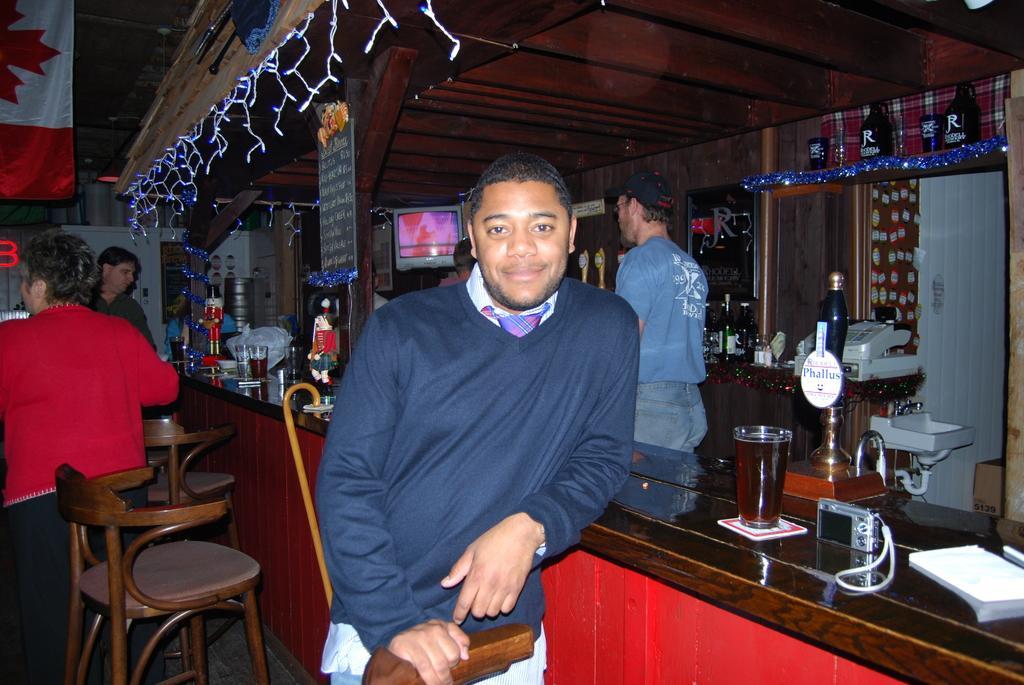Can you describe this image briefly? Front this man wore blue t-shirt and smiling and kept his hand on this table. On this table there are glasses, toys, camera and book. These persons are standing. In-front of them there are chairs. On top there is a banner. Corner there is a television. On this table there are bottles and a device. Under this device there is a sink with taps. 